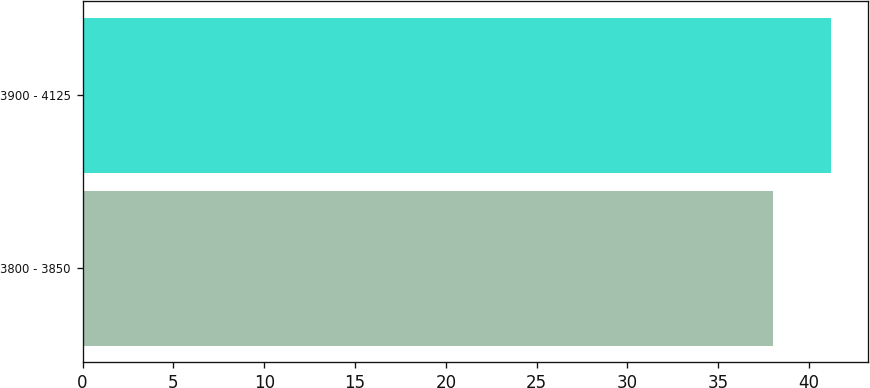Convert chart. <chart><loc_0><loc_0><loc_500><loc_500><bar_chart><fcel>3800 - 3850<fcel>3900 - 4125<nl><fcel>38<fcel>41.2<nl></chart> 